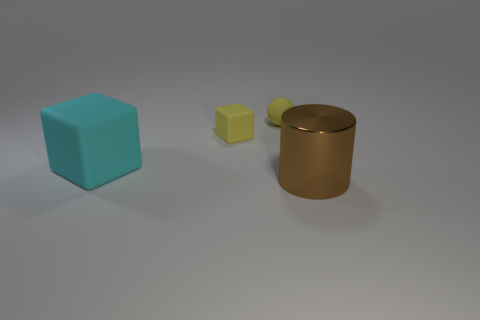There is a large object that is left of the large brown metallic object; does it have the same shape as the small yellow rubber object that is on the left side of the tiny yellow sphere?
Provide a succinct answer. Yes. What number of objects are behind the large brown cylinder and in front of the small sphere?
Offer a very short reply. 2. What number of other objects are the same size as the cyan cube?
Ensure brevity in your answer.  1. What is the thing that is in front of the tiny yellow rubber cube and to the right of the cyan rubber object made of?
Your response must be concise. Metal. There is a rubber sphere; does it have the same color as the small object that is to the left of the tiny sphere?
Make the answer very short. Yes. There is a yellow rubber object that is the same shape as the large cyan rubber object; what is its size?
Offer a very short reply. Small. What shape is the object that is both in front of the small yellow matte block and to the right of the big cyan matte block?
Give a very brief answer. Cylinder. Does the shiny cylinder have the same size as the rubber object on the left side of the yellow rubber cube?
Offer a terse response. Yes. What is the color of the other thing that is the same shape as the cyan thing?
Offer a terse response. Yellow. There is a yellow matte thing to the left of the yellow matte ball; is it the same size as the yellow ball that is behind the small yellow matte block?
Your answer should be compact. Yes. 